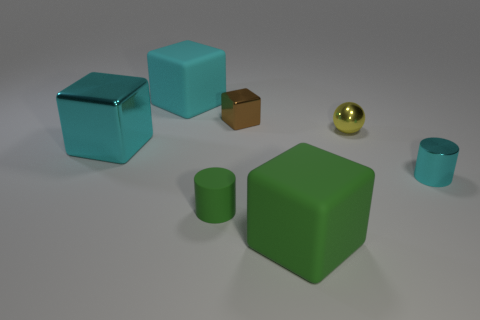What materials do the objects appear to be made of? The objects appear to have different surface textures suggesting various materials: the cubes and the cup exhibit smooth, possibly plastic surfaces, while the small brown box seems to have a rougher, more cardboard-like texture. The golden sphere looks metallic due to its reflective surface. 